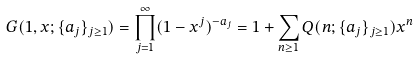<formula> <loc_0><loc_0><loc_500><loc_500>G ( 1 , x ; \{ a _ { j } \} _ { j \geq 1 } ) = \prod _ { j = 1 } ^ { \infty } ( 1 - x ^ { j } ) ^ { - a _ { j } } = 1 + \sum _ { n \geq 1 } Q ( n ; \{ a _ { j } \} _ { j \geq 1 } ) x ^ { n }</formula> 